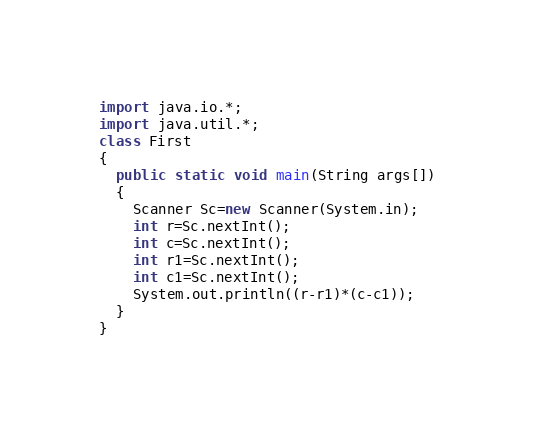Convert code to text. <code><loc_0><loc_0><loc_500><loc_500><_Java_>import java.io.*;
import java.util.*;
class First
{
  public static void main(String args[])
  {
    Scanner Sc=new Scanner(System.in);
    int r=Sc.nextInt();
    int c=Sc.nextInt();
    int r1=Sc.nextInt();
    int c1=Sc.nextInt();
    System.out.println((r-r1)*(c-c1));
  }
}</code> 